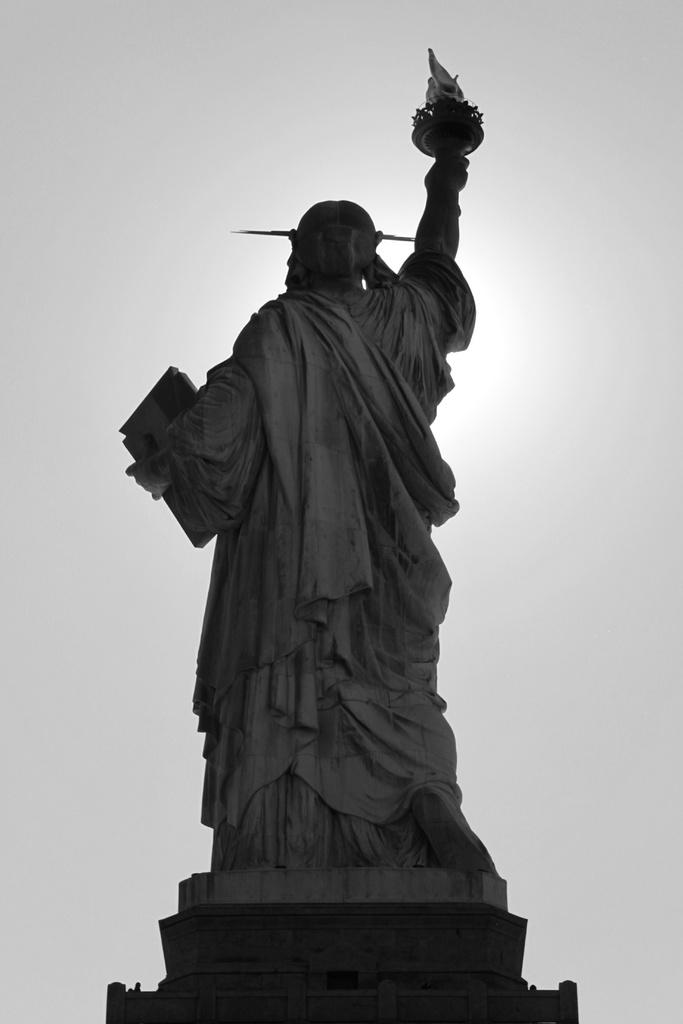What is the main subject of the image? There is a sculpture of a person standing in the image. What can be seen in the background of the image? The sky is visible in the image. How many stars are visible in the image? There is no mention of stars in the image, so it is not possible to determine how many are visible. 